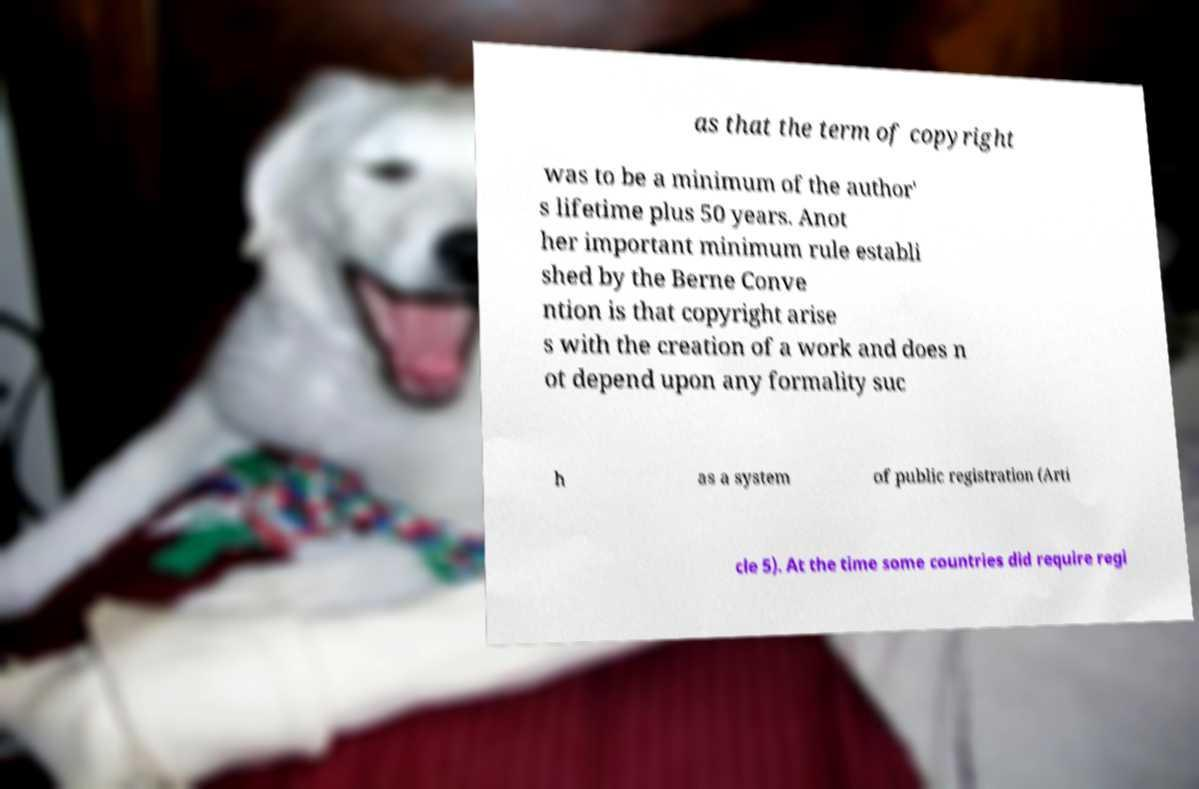Please read and relay the text visible in this image. What does it say? as that the term of copyright was to be a minimum of the author' s lifetime plus 50 years. Anot her important minimum rule establi shed by the Berne Conve ntion is that copyright arise s with the creation of a work and does n ot depend upon any formality suc h as a system of public registration (Arti cle 5). At the time some countries did require regi 